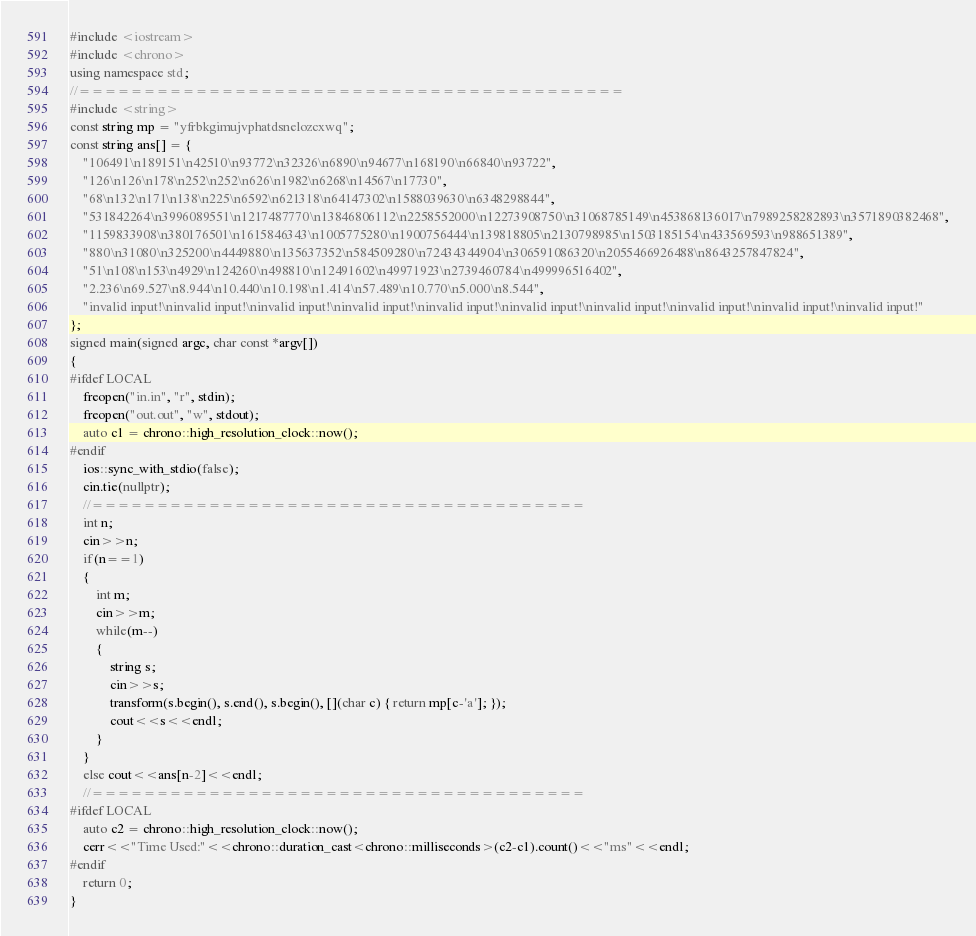<code> <loc_0><loc_0><loc_500><loc_500><_C++_>#include <iostream>
#include <chrono>
using namespace std;
//==========================================
#include <string>
const string mp = "yfrbkgimujvphatdsnelozcxwq";
const string ans[] = {
    "106491\n189151\n42510\n93772\n32326\n6890\n94677\n168190\n66840\n93722",
    "126\n126\n178\n252\n252\n626\n1982\n6268\n14567\n17730",
    "68\n132\n171\n138\n225\n6592\n621318\n64147302\n1588039630\n6348298844",
    "531842264\n3996089551\n1217487770\n13846806112\n2258552000\n12273908750\n31068785149\n453868136017\n7989258282893\n3571890382468",
    "1159833908\n380176501\n1615846343\n1005775280\n1900756444\n139818805\n2130798985\n1503185154\n433569593\n988651389",
    "880\n31080\n325200\n4449880\n135637352\n584509280\n72434344904\n306591086320\n2055466926488\n8643257847824",
    "51\n108\n153\n4929\n124260\n498810\n12491602\n49971923\n2739460784\n499996516402",
    "2.236\n69.527\n8.944\n10.440\n10.198\n1.414\n57.489\n10.770\n5.000\n8.544",
    "invalid input!\ninvalid input!\ninvalid input!\ninvalid input!\ninvalid input!\ninvalid input!\ninvalid input!\ninvalid input!\ninvalid input!\ninvalid input!"
};
signed main(signed argc, char const *argv[])
{
#ifdef LOCAL
    freopen("in.in", "r", stdin);
    freopen("out.out", "w", stdout);
    auto c1 = chrono::high_resolution_clock::now();
#endif
    ios::sync_with_stdio(false);
    cin.tie(nullptr);
    //======================================
    int n;
    cin>>n;
    if(n==1)
    {
        int m;
        cin>>m;
        while(m--)
        {
            string s;
            cin>>s;
            transform(s.begin(), s.end(), s.begin(), [](char c) { return mp[c-'a']; });
            cout<<s<<endl;
        }
    }
    else cout<<ans[n-2]<<endl;
    //======================================
#ifdef LOCAL
    auto c2 = chrono::high_resolution_clock::now();
    cerr<<"Time Used:"<<chrono::duration_cast<chrono::milliseconds>(c2-c1).count()<<"ms"<<endl;
#endif
    return 0;
}</code> 